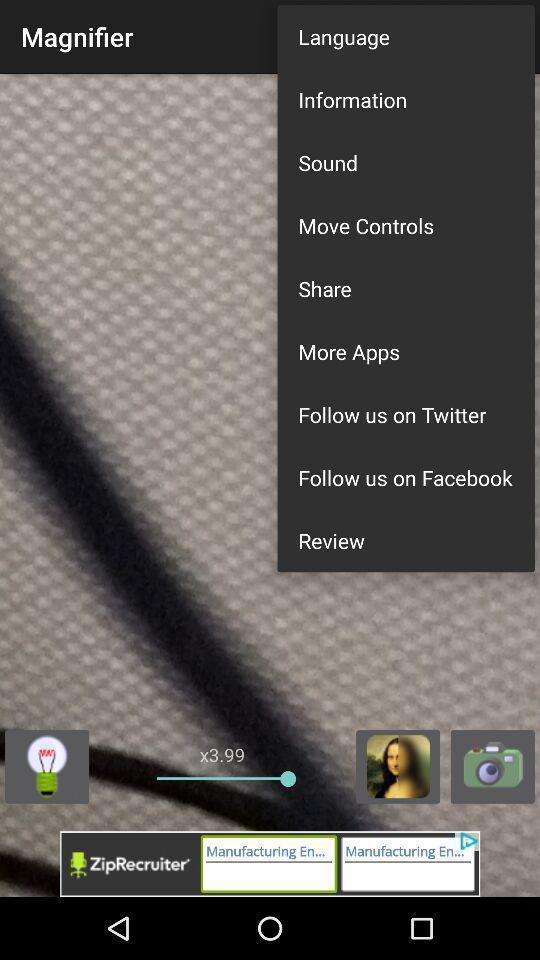What can you discern from this picture? Pop up showing different options on an editing app. 